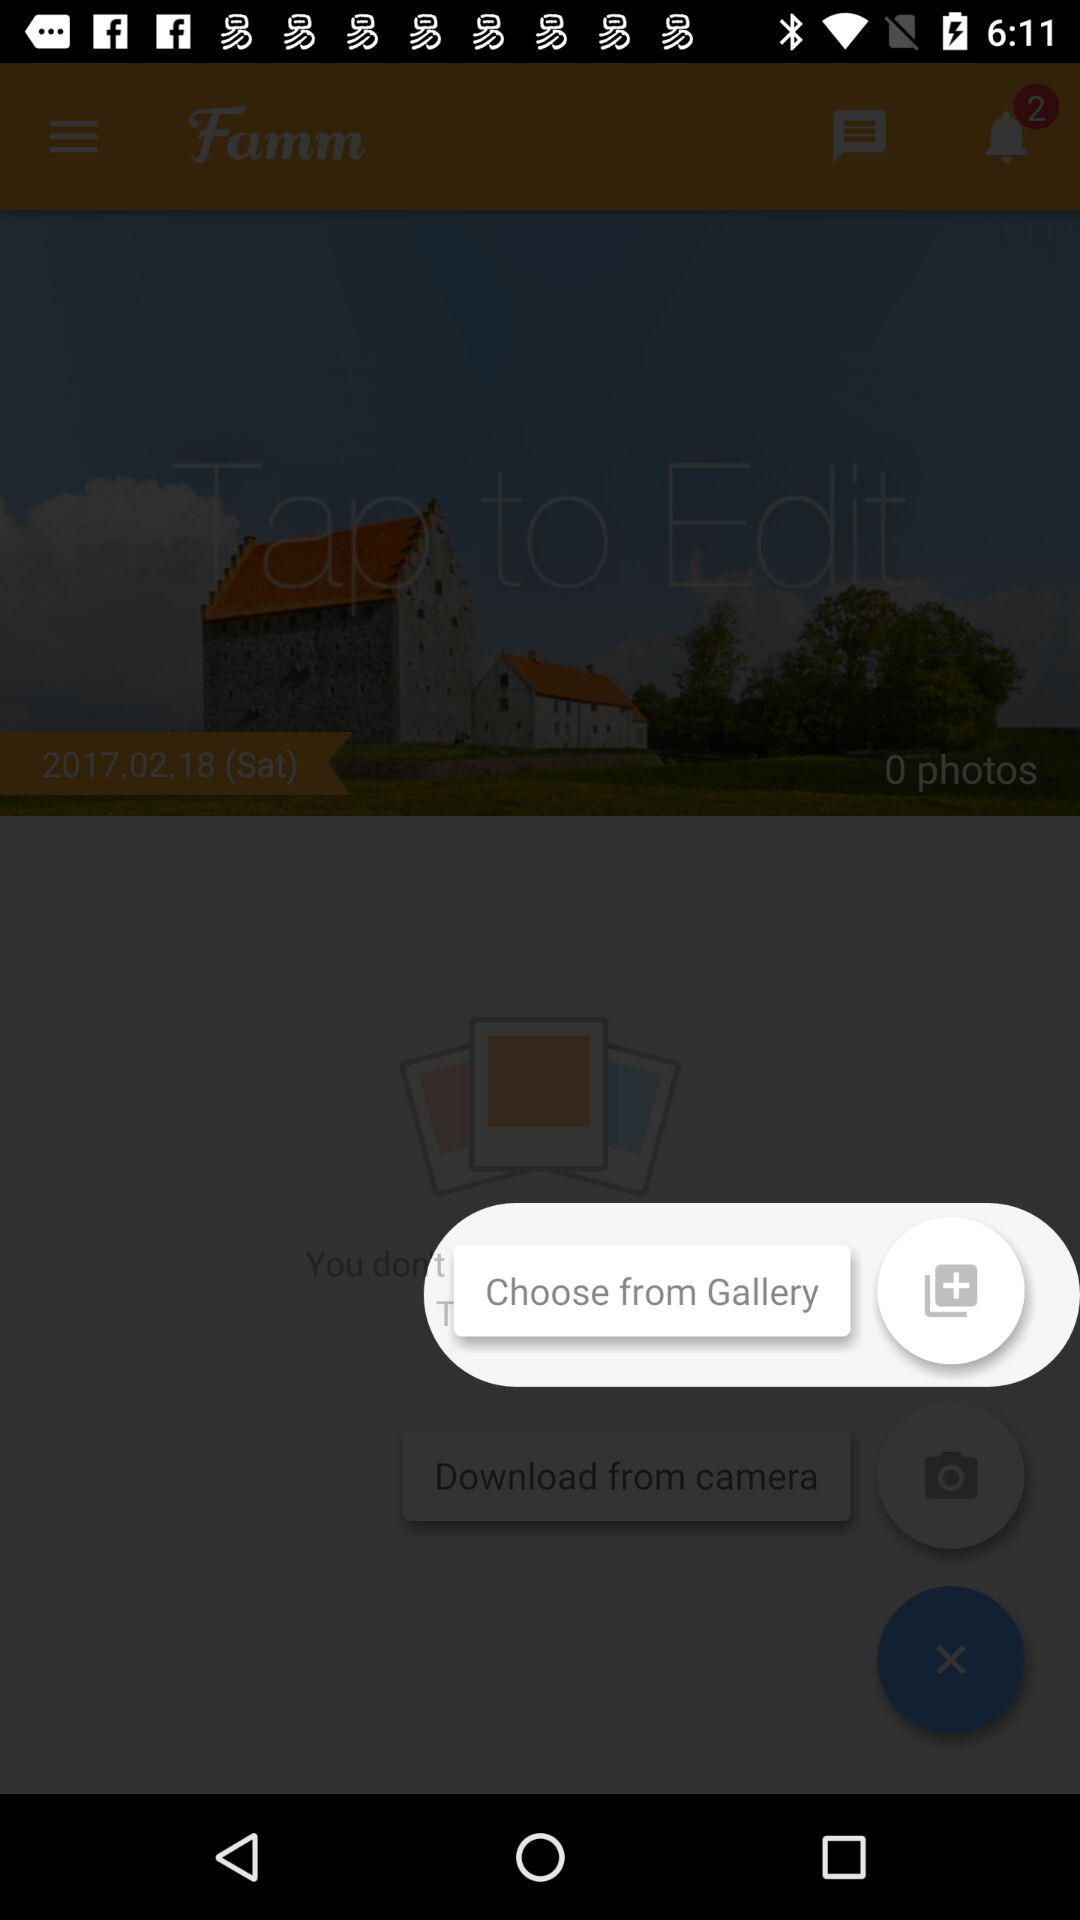What is the date? The date is Saturday, February 18, 2017. 